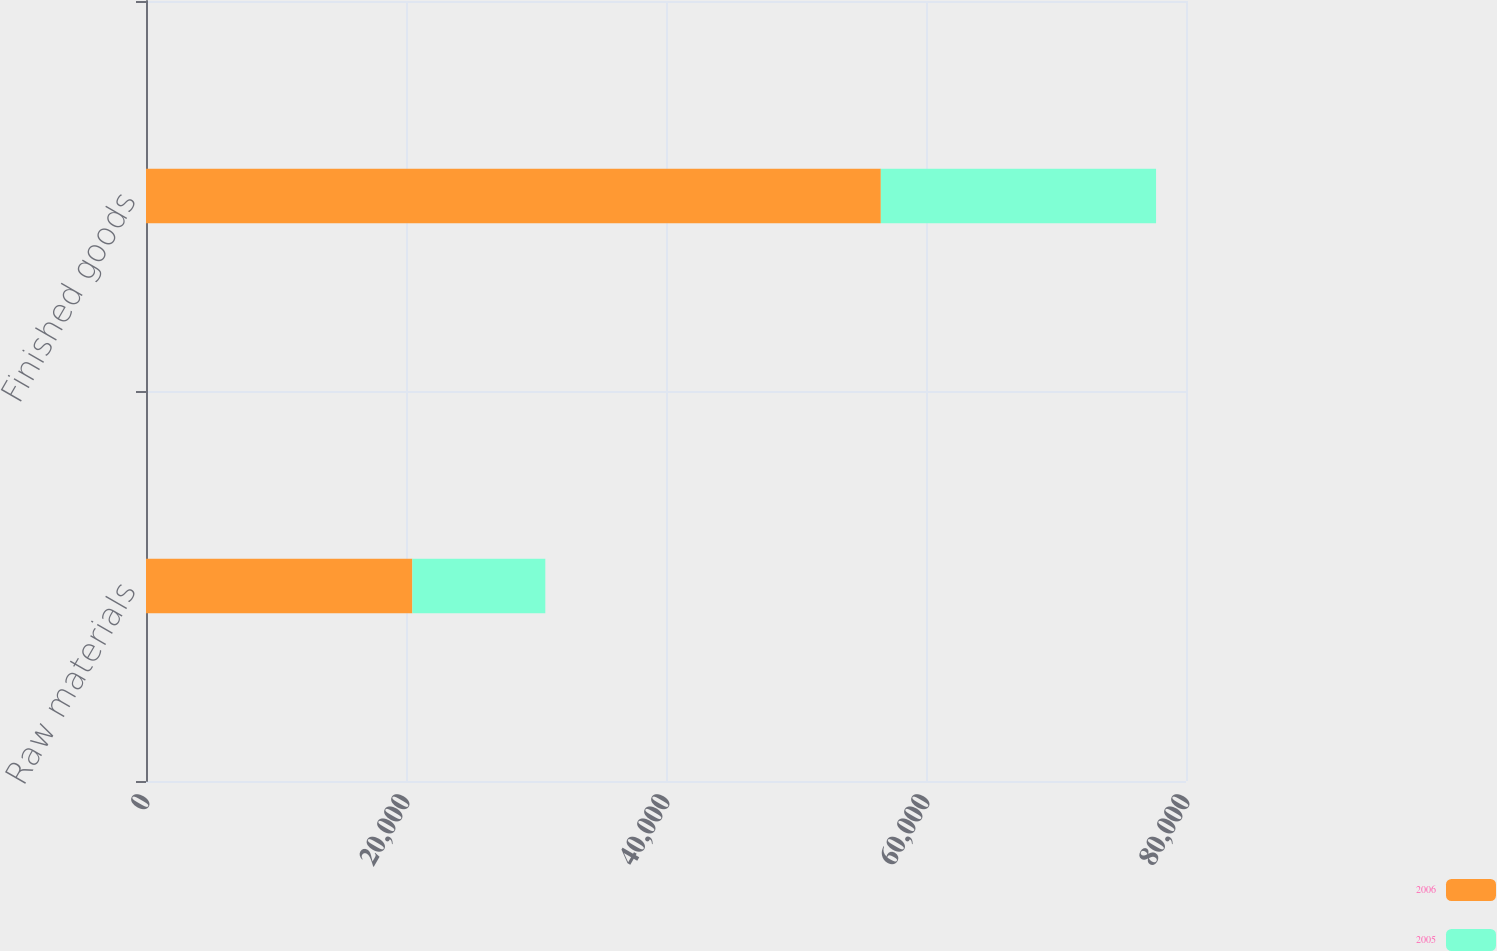<chart> <loc_0><loc_0><loc_500><loc_500><stacked_bar_chart><ecel><fcel>Raw materials<fcel>Finished goods<nl><fcel>2006<fcel>20488<fcel>56525<nl><fcel>2005<fcel>10228<fcel>21172<nl></chart> 